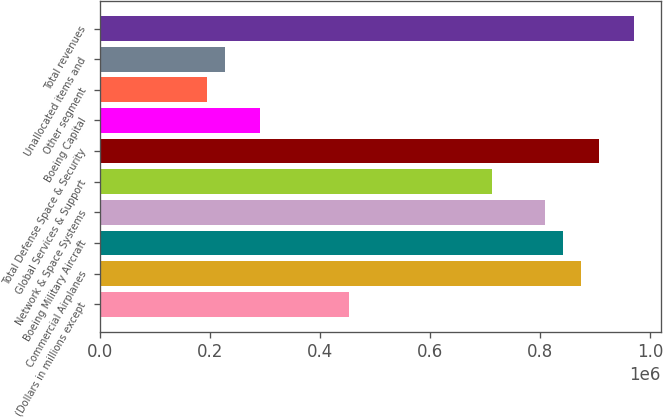Convert chart. <chart><loc_0><loc_0><loc_500><loc_500><bar_chart><fcel>(Dollars in millions except<fcel>Commercial Airplanes<fcel>Boeing Military Aircraft<fcel>Network & Space Systems<fcel>Global Services & Support<fcel>Total Defense Space & Security<fcel>Boeing Capital<fcel>Other segment<fcel>Unallocated items and<fcel>Total revenues<nl><fcel>453403<fcel>874419<fcel>842033<fcel>809648<fcel>712490<fcel>906805<fcel>291474<fcel>194317<fcel>226702<fcel>971577<nl></chart> 